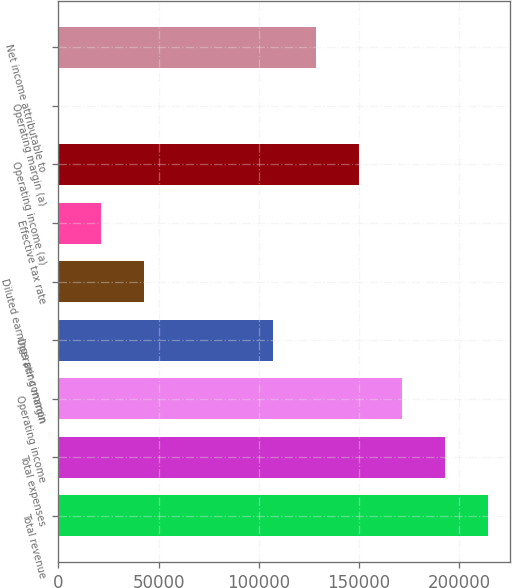Convert chart to OTSL. <chart><loc_0><loc_0><loc_500><loc_500><bar_chart><fcel>Total revenue<fcel>Total expenses<fcel>Operating income<fcel>Operating margin<fcel>Diluted earnings per common<fcel>Effective tax rate<fcel>Operating income (a)<fcel>Operating margin (a)<fcel>Net income attributable to<nl><fcel>214712<fcel>193241<fcel>171770<fcel>107357<fcel>42943.3<fcel>21472.2<fcel>150299<fcel>1.1<fcel>128828<nl></chart> 